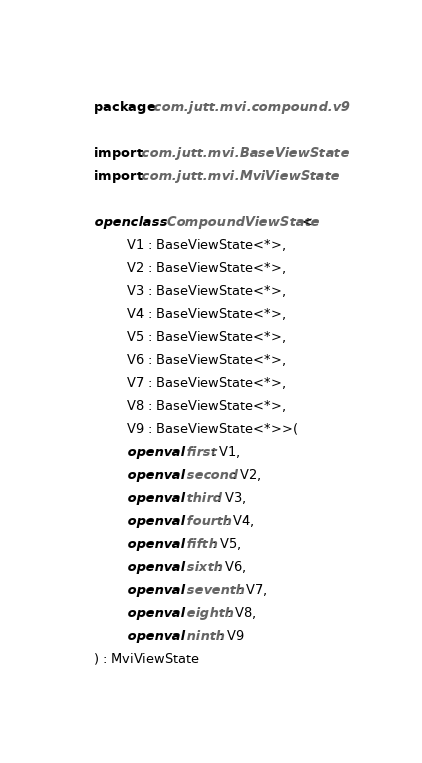<code> <loc_0><loc_0><loc_500><loc_500><_Kotlin_>package com.jutt.mvi.compound.v9

import com.jutt.mvi.BaseViewState
import com.jutt.mvi.MviViewState

open class CompoundViewState<
        V1 : BaseViewState<*>,
        V2 : BaseViewState<*>,
        V3 : BaseViewState<*>,
        V4 : BaseViewState<*>,
        V5 : BaseViewState<*>,
        V6 : BaseViewState<*>,
        V7 : BaseViewState<*>,
        V8 : BaseViewState<*>,
        V9 : BaseViewState<*>>(
        open val first: V1,
        open val second: V2,
        open val third: V3,
        open val fourth: V4,
        open val fifth: V5,
        open val sixth: V6,
        open val seventh: V7,
        open val eighth: V8,
        open val ninth: V9
) : MviViewState</code> 